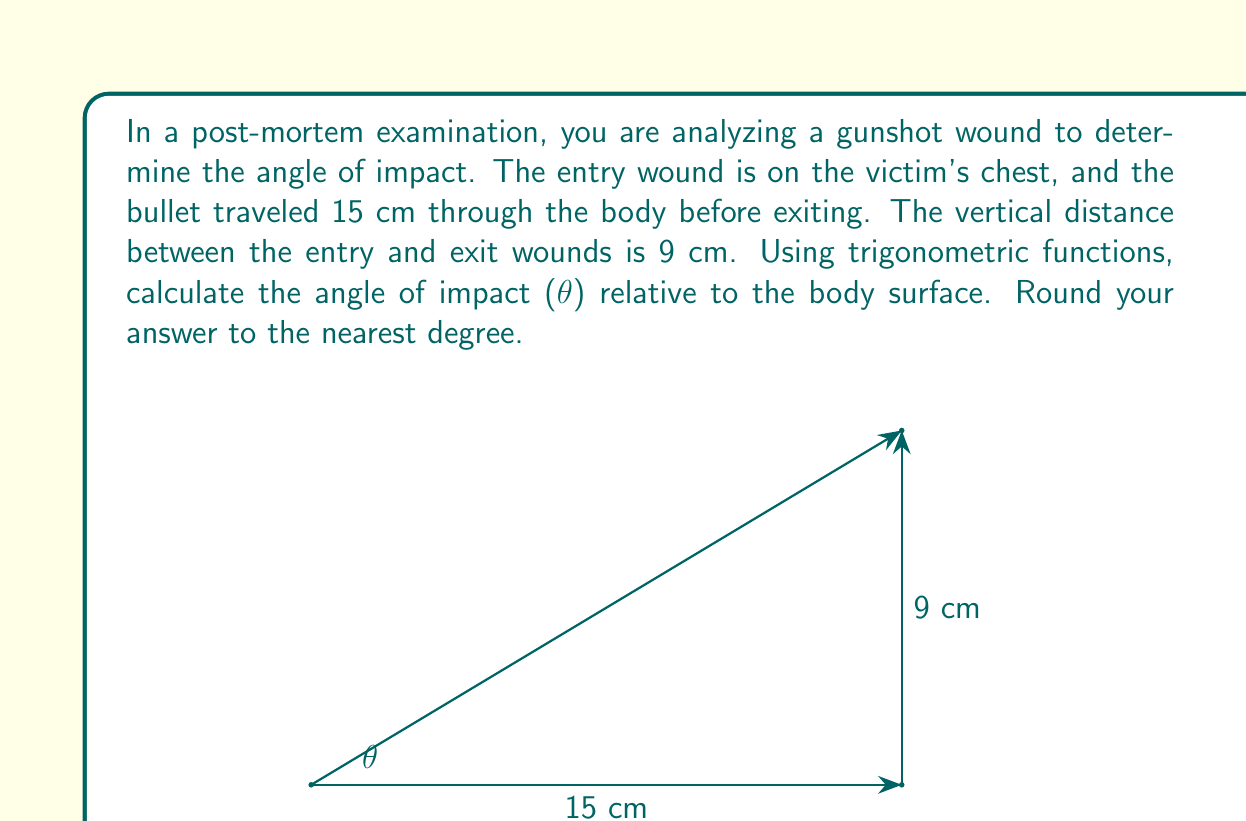Can you solve this math problem? To solve this problem, we can use the trigonometric function tangent (tan). In a right triangle, tan is the ratio of the opposite side to the adjacent side.

1) First, let's identify the sides of our right triangle:
   - The opposite side is the vertical distance between entry and exit wounds: 9 cm
   - The adjacent side is the horizontal distance the bullet traveled: 15 cm

2) We can set up the equation:

   $$\tan(\theta) = \frac{\text{opposite}}{\text{adjacent}} = \frac{9}{15}$$

3) To find θ, we need to use the inverse tangent function (arctan or $\tan^{-1}$):

   $$\theta = \tan^{-1}\left(\frac{9}{15}\right)$$

4) Using a calculator or computer:

   $$\theta \approx 30.9638^\circ$$

5) Rounding to the nearest degree:

   $$\theta \approx 31^\circ$$

Therefore, the angle of impact relative to the body surface is approximately 31°.
Answer: $31^\circ$ 